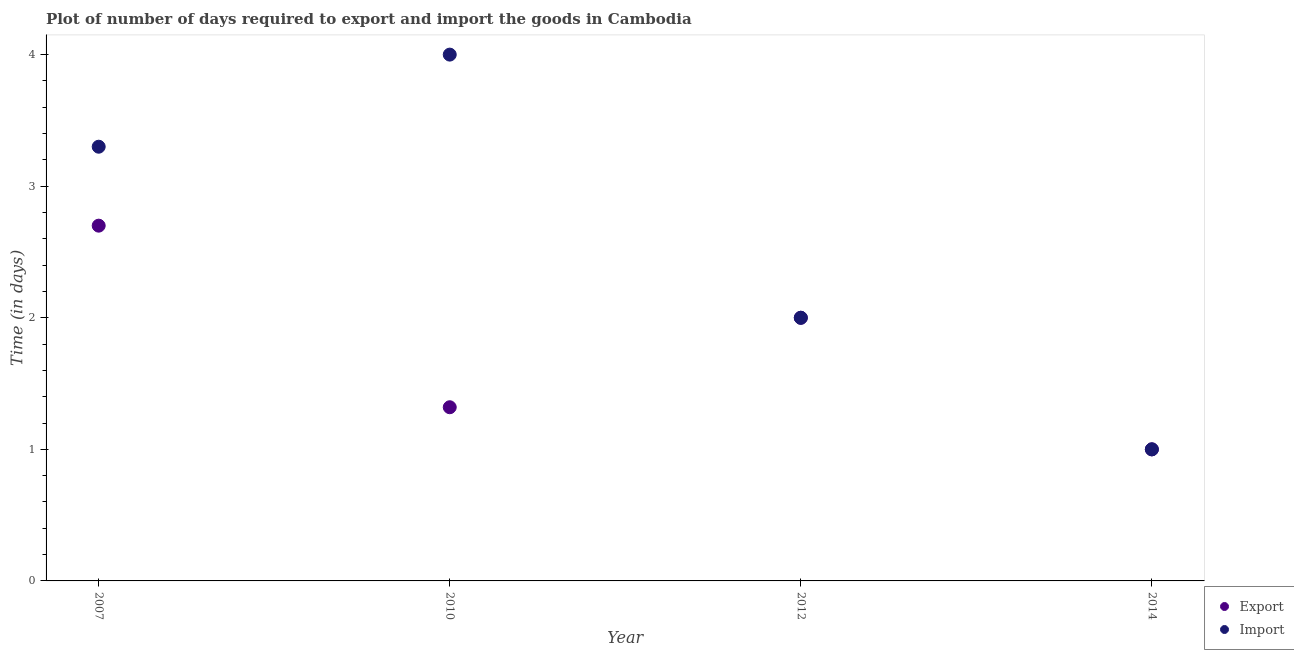Is the number of dotlines equal to the number of legend labels?
Your answer should be very brief. Yes. What is the time required to export in 2010?
Make the answer very short. 1.32. Across all years, what is the minimum time required to export?
Ensure brevity in your answer.  1. In which year was the time required to import maximum?
Ensure brevity in your answer.  2010. In which year was the time required to export minimum?
Your answer should be very brief. 2014. What is the total time required to export in the graph?
Give a very brief answer. 7.02. What is the difference between the time required to export in 2007 and the time required to import in 2012?
Your response must be concise. 0.7. What is the average time required to export per year?
Offer a terse response. 1.76. In the year 2007, what is the difference between the time required to import and time required to export?
Provide a short and direct response. 0.6. What is the ratio of the time required to import in 2007 to that in 2012?
Your answer should be compact. 1.65. What is the difference between the highest and the second highest time required to import?
Ensure brevity in your answer.  0.7. What is the difference between the highest and the lowest time required to export?
Ensure brevity in your answer.  1.7. In how many years, is the time required to import greater than the average time required to import taken over all years?
Your answer should be very brief. 2. Is the time required to export strictly greater than the time required to import over the years?
Provide a short and direct response. No. How many years are there in the graph?
Your response must be concise. 4. What is the difference between two consecutive major ticks on the Y-axis?
Provide a short and direct response. 1. Are the values on the major ticks of Y-axis written in scientific E-notation?
Your answer should be compact. No. How are the legend labels stacked?
Make the answer very short. Vertical. What is the title of the graph?
Give a very brief answer. Plot of number of days required to export and import the goods in Cambodia. Does "Male" appear as one of the legend labels in the graph?
Ensure brevity in your answer.  No. What is the label or title of the Y-axis?
Keep it short and to the point. Time (in days). What is the Time (in days) of Export in 2007?
Your answer should be compact. 2.7. What is the Time (in days) of Export in 2010?
Keep it short and to the point. 1.32. What is the Time (in days) of Export in 2012?
Offer a terse response. 2. What is the Time (in days) in Import in 2012?
Keep it short and to the point. 2. What is the Time (in days) of Export in 2014?
Give a very brief answer. 1. Across all years, what is the maximum Time (in days) in Export?
Offer a very short reply. 2.7. Across all years, what is the maximum Time (in days) of Import?
Make the answer very short. 4. Across all years, what is the minimum Time (in days) of Import?
Provide a short and direct response. 1. What is the total Time (in days) in Export in the graph?
Ensure brevity in your answer.  7.02. What is the difference between the Time (in days) of Export in 2007 and that in 2010?
Your answer should be compact. 1.38. What is the difference between the Time (in days) in Export in 2007 and that in 2014?
Give a very brief answer. 1.7. What is the difference between the Time (in days) in Import in 2007 and that in 2014?
Ensure brevity in your answer.  2.3. What is the difference between the Time (in days) of Export in 2010 and that in 2012?
Your response must be concise. -0.68. What is the difference between the Time (in days) in Export in 2010 and that in 2014?
Offer a terse response. 0.32. What is the difference between the Time (in days) of Import in 2010 and that in 2014?
Offer a terse response. 3. What is the difference between the Time (in days) of Import in 2012 and that in 2014?
Offer a terse response. 1. What is the difference between the Time (in days) of Export in 2007 and the Time (in days) of Import in 2012?
Offer a terse response. 0.7. What is the difference between the Time (in days) of Export in 2010 and the Time (in days) of Import in 2012?
Ensure brevity in your answer.  -0.68. What is the difference between the Time (in days) of Export in 2010 and the Time (in days) of Import in 2014?
Offer a very short reply. 0.32. What is the average Time (in days) of Export per year?
Provide a short and direct response. 1.75. What is the average Time (in days) in Import per year?
Offer a very short reply. 2.58. In the year 2007, what is the difference between the Time (in days) of Export and Time (in days) of Import?
Your answer should be very brief. -0.6. In the year 2010, what is the difference between the Time (in days) in Export and Time (in days) in Import?
Ensure brevity in your answer.  -2.68. In the year 2012, what is the difference between the Time (in days) in Export and Time (in days) in Import?
Keep it short and to the point. 0. What is the ratio of the Time (in days) of Export in 2007 to that in 2010?
Offer a terse response. 2.05. What is the ratio of the Time (in days) of Import in 2007 to that in 2010?
Make the answer very short. 0.82. What is the ratio of the Time (in days) of Export in 2007 to that in 2012?
Provide a succinct answer. 1.35. What is the ratio of the Time (in days) of Import in 2007 to that in 2012?
Offer a very short reply. 1.65. What is the ratio of the Time (in days) of Export in 2007 to that in 2014?
Your answer should be very brief. 2.7. What is the ratio of the Time (in days) in Import in 2007 to that in 2014?
Your answer should be compact. 3.3. What is the ratio of the Time (in days) in Export in 2010 to that in 2012?
Keep it short and to the point. 0.66. What is the ratio of the Time (in days) of Export in 2010 to that in 2014?
Provide a short and direct response. 1.32. What is the ratio of the Time (in days) of Export in 2012 to that in 2014?
Your answer should be compact. 2. What is the difference between the highest and the second highest Time (in days) in Export?
Make the answer very short. 0.7. What is the difference between the highest and the second highest Time (in days) in Import?
Provide a succinct answer. 0.7. What is the difference between the highest and the lowest Time (in days) in Export?
Make the answer very short. 1.7. What is the difference between the highest and the lowest Time (in days) in Import?
Ensure brevity in your answer.  3. 